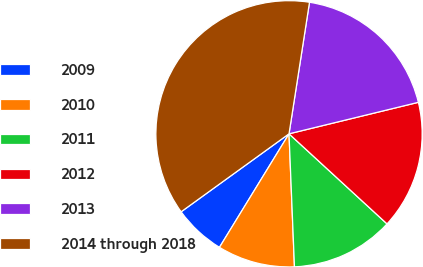Convert chart to OTSL. <chart><loc_0><loc_0><loc_500><loc_500><pie_chart><fcel>2009<fcel>2010<fcel>2011<fcel>2012<fcel>2013<fcel>2014 through 2018<nl><fcel>6.29%<fcel>9.4%<fcel>12.52%<fcel>15.63%<fcel>18.74%<fcel>37.42%<nl></chart> 